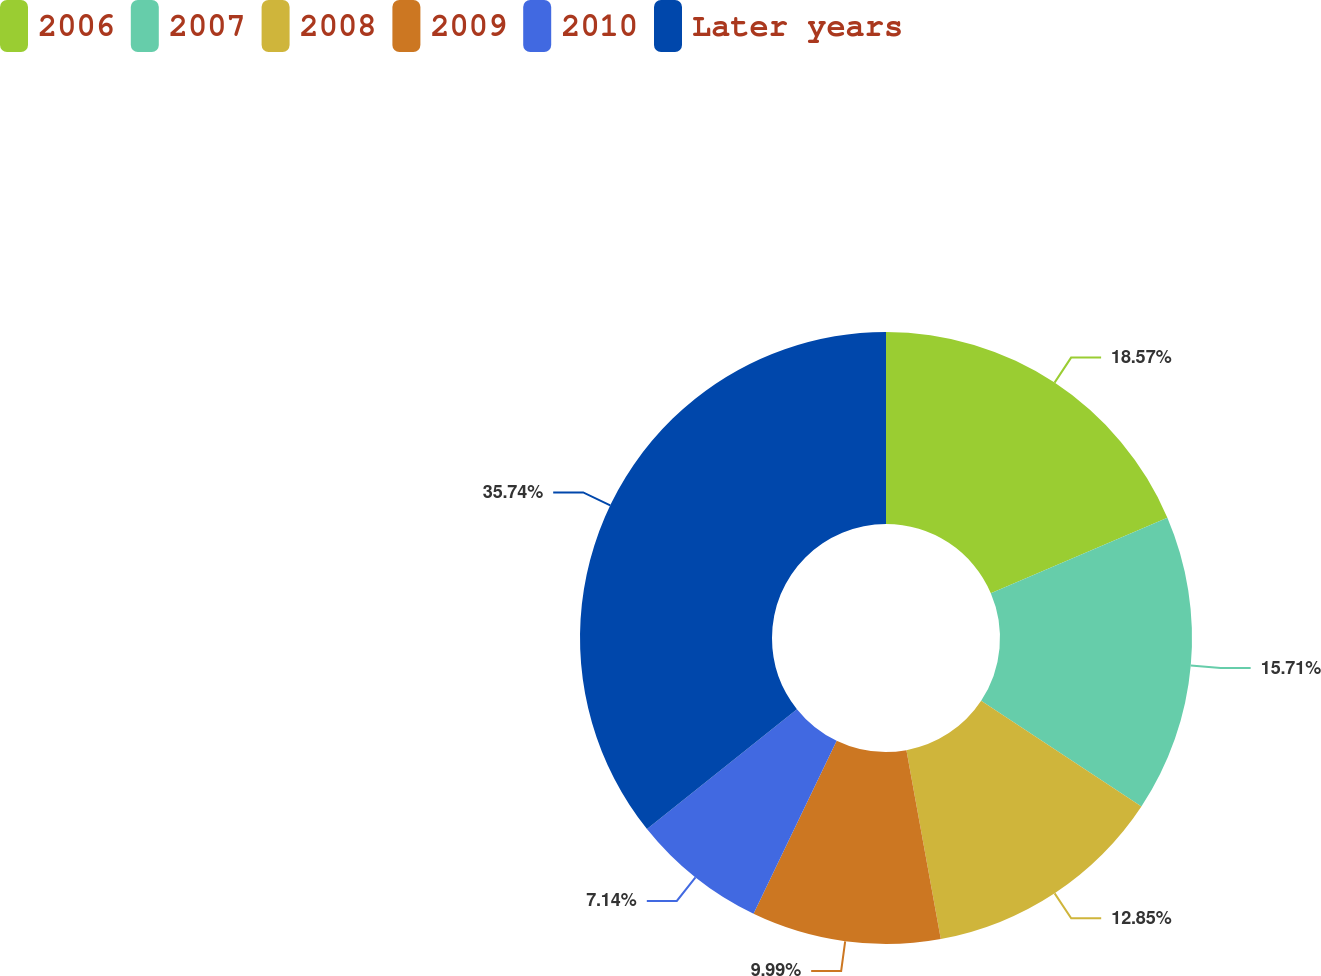Convert chart. <chart><loc_0><loc_0><loc_500><loc_500><pie_chart><fcel>2006<fcel>2007<fcel>2008<fcel>2009<fcel>2010<fcel>Later years<nl><fcel>18.57%<fcel>15.71%<fcel>12.85%<fcel>9.99%<fcel>7.14%<fcel>35.73%<nl></chart> 